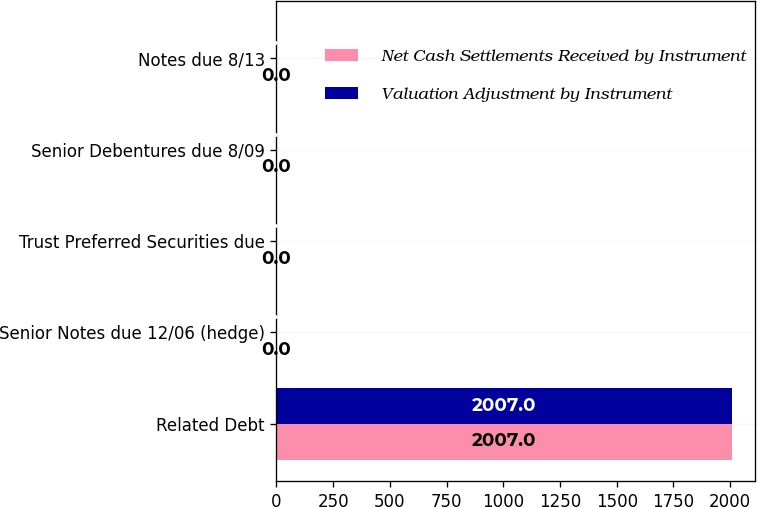<chart> <loc_0><loc_0><loc_500><loc_500><stacked_bar_chart><ecel><fcel>Related Debt<fcel>Senior Notes due 12/06 (hedge)<fcel>Trust Preferred Securities due<fcel>Senior Debentures due 8/09<fcel>Notes due 8/13<nl><fcel>Net Cash Settlements Received by Instrument<fcel>2007<fcel>0<fcel>0<fcel>0<fcel>0<nl><fcel>Valuation Adjustment by Instrument<fcel>2007<fcel>0<fcel>0<fcel>0<fcel>0<nl></chart> 